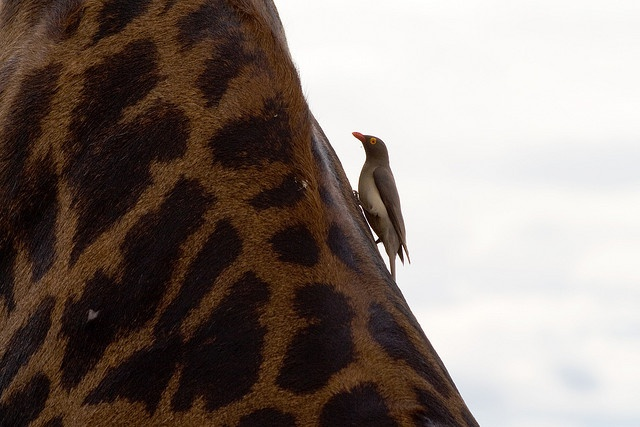Describe the objects in this image and their specific colors. I can see giraffe in gray, black, and maroon tones and bird in gray, black, and maroon tones in this image. 